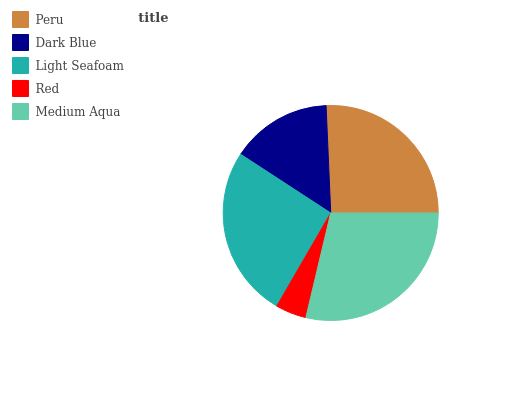Is Red the minimum?
Answer yes or no. Yes. Is Medium Aqua the maximum?
Answer yes or no. Yes. Is Dark Blue the minimum?
Answer yes or no. No. Is Dark Blue the maximum?
Answer yes or no. No. Is Peru greater than Dark Blue?
Answer yes or no. Yes. Is Dark Blue less than Peru?
Answer yes or no. Yes. Is Dark Blue greater than Peru?
Answer yes or no. No. Is Peru less than Dark Blue?
Answer yes or no. No. Is Peru the high median?
Answer yes or no. Yes. Is Peru the low median?
Answer yes or no. Yes. Is Red the high median?
Answer yes or no. No. Is Light Seafoam the low median?
Answer yes or no. No. 